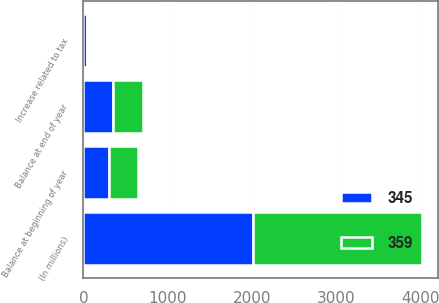Convert chart to OTSL. <chart><loc_0><loc_0><loc_500><loc_500><stacked_bar_chart><ecel><fcel>(In millions)<fcel>Balance at beginning of year<fcel>Increase related to tax<fcel>Balance at end of year<nl><fcel>359<fcel>2009<fcel>345<fcel>14<fcel>359<nl><fcel>345<fcel>2008<fcel>305<fcel>41<fcel>345<nl></chart> 